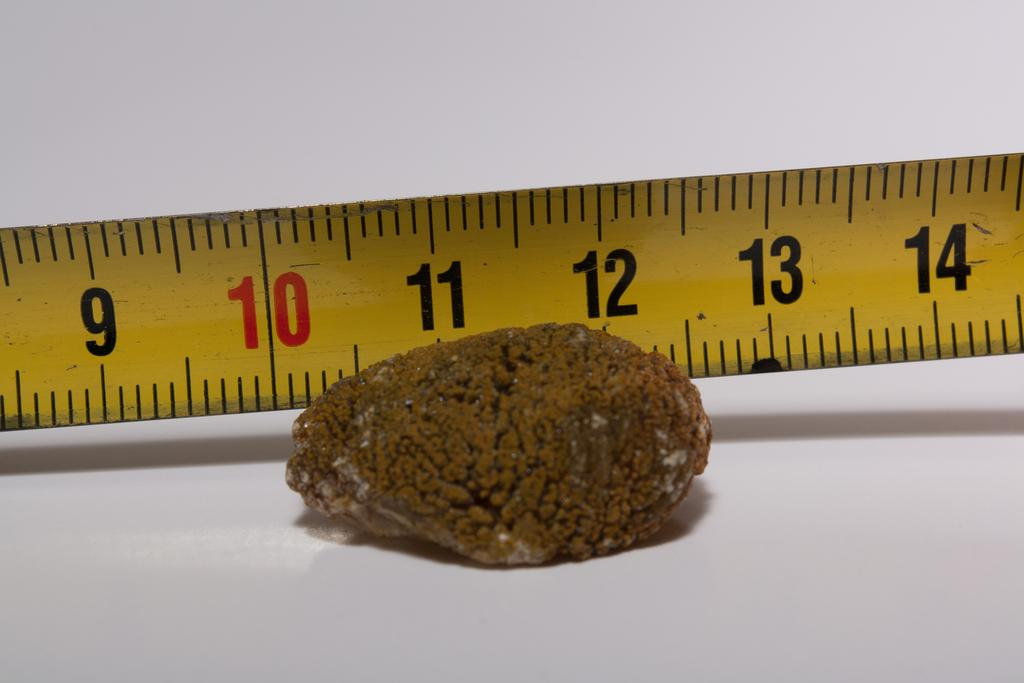<image>
Share a concise interpretation of the image provided. A sea sponge is approximately 2 inches long, starting at the 10 and ending at the 12. 